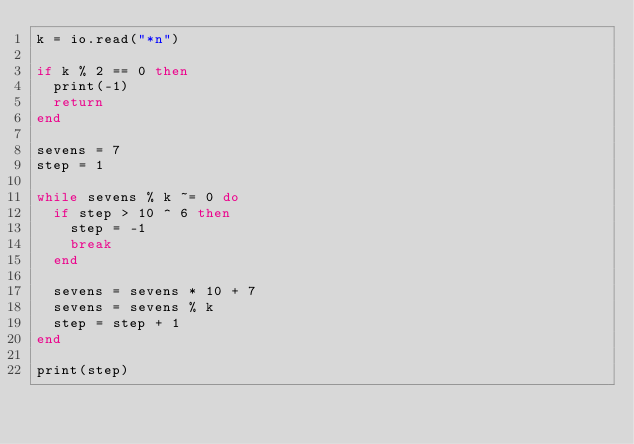Convert code to text. <code><loc_0><loc_0><loc_500><loc_500><_Lua_>k = io.read("*n")

if k % 2 == 0 then
  print(-1)
  return
end

sevens = 7
step = 1

while sevens % k ~= 0 do
  if step > 10 ^ 6 then
    step = -1
    break
  end

  sevens = sevens * 10 + 7
  sevens = sevens % k
  step = step + 1
end

print(step)
</code> 